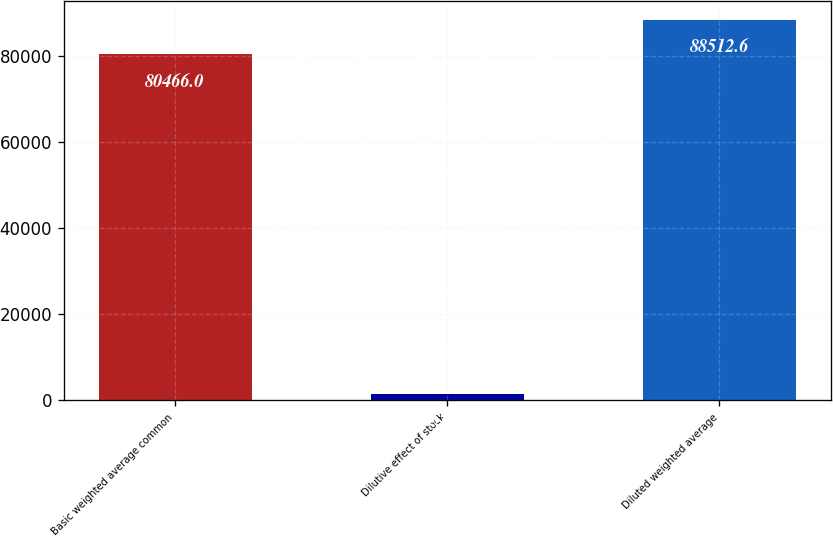<chart> <loc_0><loc_0><loc_500><loc_500><bar_chart><fcel>Basic weighted average common<fcel>Dilutive effect of stock<fcel>Diluted weighted average<nl><fcel>80466<fcel>1517<fcel>88512.6<nl></chart> 